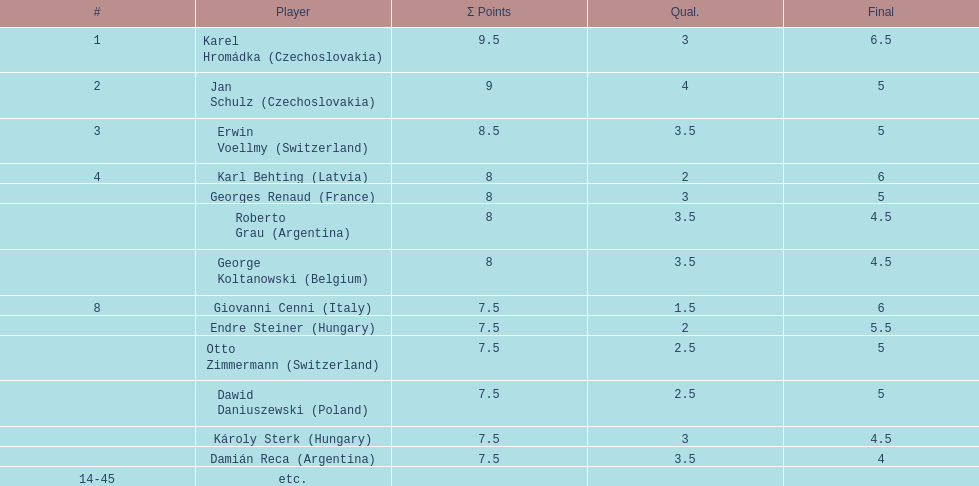The most points were scored by which player? Karel Hromádka. 